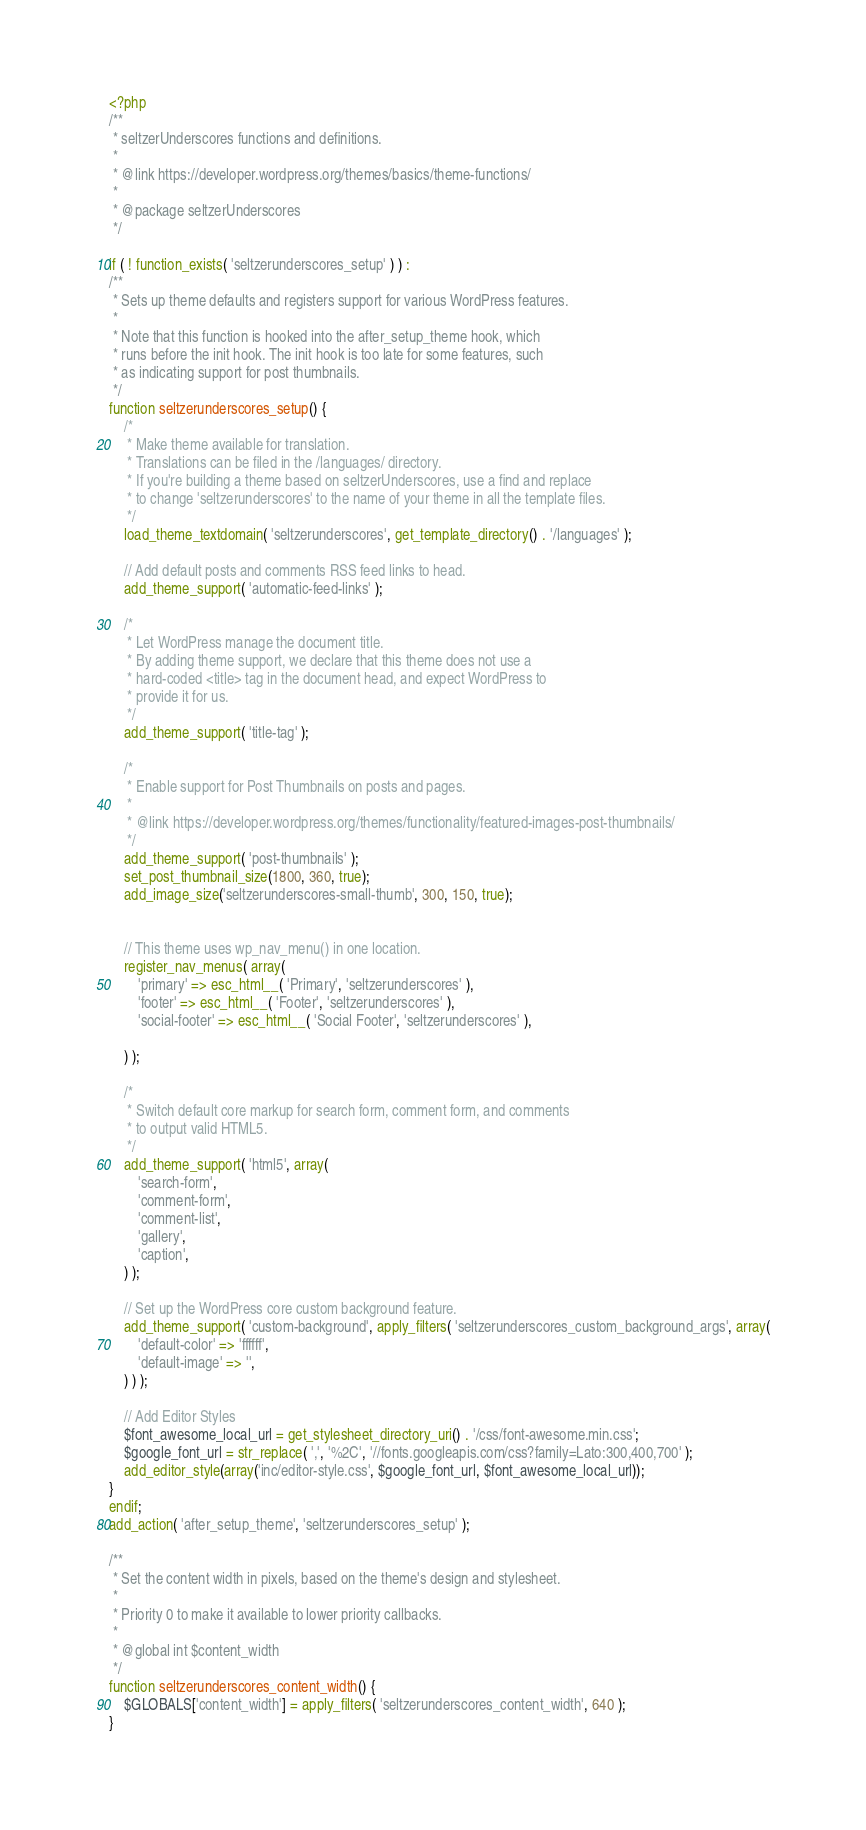Convert code to text. <code><loc_0><loc_0><loc_500><loc_500><_PHP_><?php
/**
 * seltzerUnderscores functions and definitions.
 *
 * @link https://developer.wordpress.org/themes/basics/theme-functions/
 *
 * @package seltzerUnderscores
 */

if ( ! function_exists( 'seltzerunderscores_setup' ) ) :
/**
 * Sets up theme defaults and registers support for various WordPress features.
 *
 * Note that this function is hooked into the after_setup_theme hook, which
 * runs before the init hook. The init hook is too late for some features, such
 * as indicating support for post thumbnails.
 */
function seltzerunderscores_setup() {
	/*
	 * Make theme available for translation.
	 * Translations can be filed in the /languages/ directory.
	 * If you're building a theme based on seltzerUnderscores, use a find and replace
	 * to change 'seltzerunderscores' to the name of your theme in all the template files.
	 */
	load_theme_textdomain( 'seltzerunderscores', get_template_directory() . '/languages' );

	// Add default posts and comments RSS feed links to head.
	add_theme_support( 'automatic-feed-links' );

	/*
	 * Let WordPress manage the document title.
	 * By adding theme support, we declare that this theme does not use a
	 * hard-coded <title> tag in the document head, and expect WordPress to
	 * provide it for us.
	 */
	add_theme_support( 'title-tag' );

	/*
	 * Enable support for Post Thumbnails on posts and pages.
	 *
	 * @link https://developer.wordpress.org/themes/functionality/featured-images-post-thumbnails/
	 */
	add_theme_support( 'post-thumbnails' );
	set_post_thumbnail_size(1800, 360, true);
	add_image_size('seltzerunderscores-small-thumb', 300, 150, true);


	// This theme uses wp_nav_menu() in one location.
	register_nav_menus( array(
		'primary' => esc_html__( 'Primary', 'seltzerunderscores' ),
		'footer' => esc_html__( 'Footer', 'seltzerunderscores' ),
		'social-footer' => esc_html__( 'Social Footer', 'seltzerunderscores' ),

	) );

	/*
	 * Switch default core markup for search form, comment form, and comments
	 * to output valid HTML5.
	 */
	add_theme_support( 'html5', array(
		'search-form',
		'comment-form',
		'comment-list',
		'gallery',
		'caption',
	) );

	// Set up the WordPress core custom background feature.
	add_theme_support( 'custom-background', apply_filters( 'seltzerunderscores_custom_background_args', array(
		'default-color' => 'ffffff',
		'default-image' => '',
	) ) );

	// Add Editor Styles
	$font_awesome_local_url = get_stylesheet_directory_uri() . '/css/font-awesome.min.css';
	$google_font_url = str_replace( ',', '%2C', '//fonts.googleapis.com/css?family=Lato:300,400,700' );
	add_editor_style(array('inc/editor-style.css', $google_font_url, $font_awesome_local_url));
}
endif;
add_action( 'after_setup_theme', 'seltzerunderscores_setup' );

/**
 * Set the content width in pixels, based on the theme's design and stylesheet.
 *
 * Priority 0 to make it available to lower priority callbacks.
 *
 * @global int $content_width
 */
function seltzerunderscores_content_width() {
	$GLOBALS['content_width'] = apply_filters( 'seltzerunderscores_content_width', 640 );
}</code> 